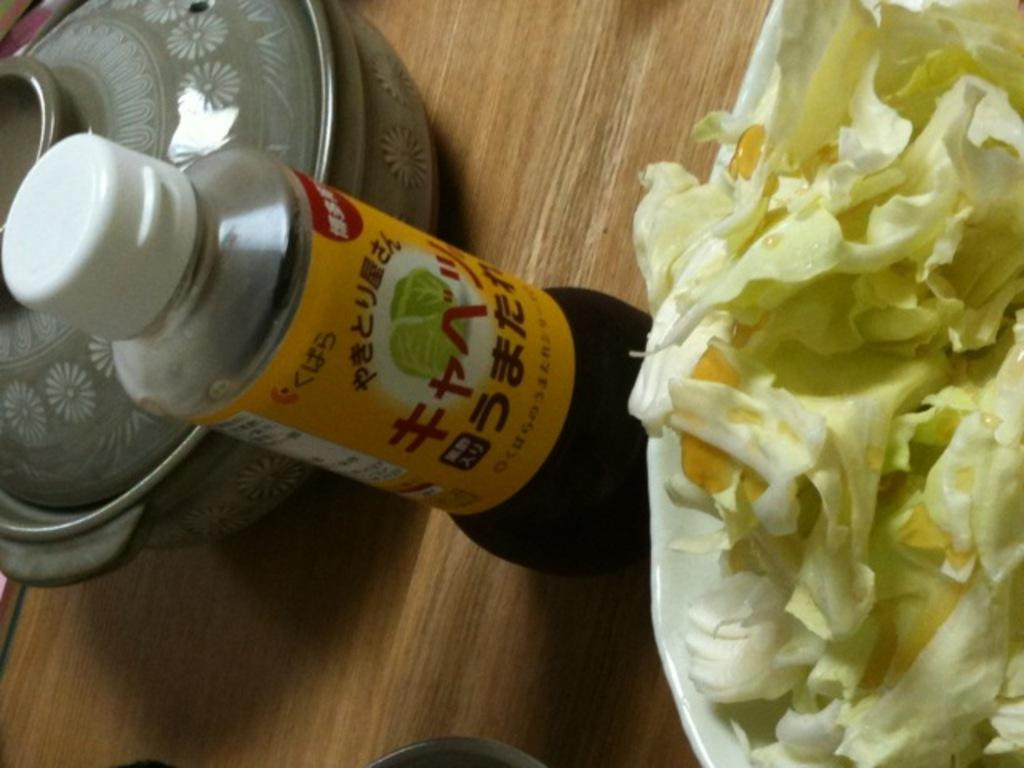What is the main subject on the table in the image? There is a food item on a table in the image. What else can be seen on the table besides the food item? There is a bottle and a ceramic bowl in the image. How many brothers are depicted in the image? There are no brothers present in the image. Is there any blood visible in the image? There is no blood visible in the image. 